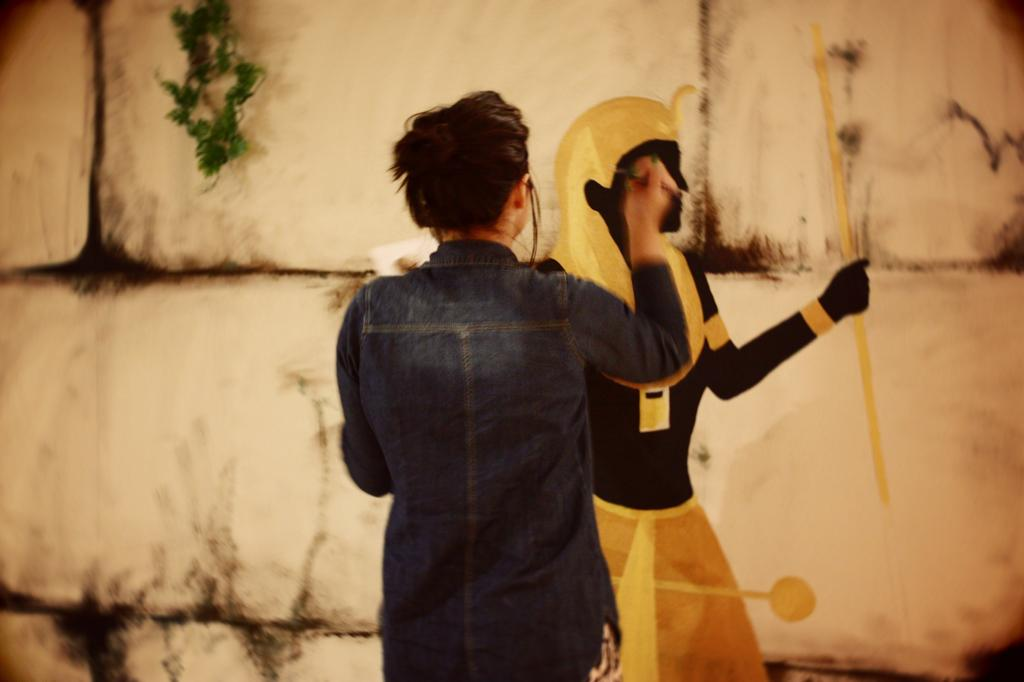What is the person in the image doing? The person is standing and painting on a wall. What is the subject of the painting? The provided facts do not specify the subject of the painting, so we cannot determine that from the image. What type of vegetation can be seen in the image? Green leaves are visible in the image. What type of silverware is being used to sing songs in the image? There is no silverware or singing in the image; it features a person painting on a wall and green leaves. 